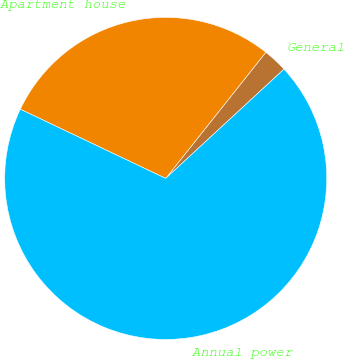<chart> <loc_0><loc_0><loc_500><loc_500><pie_chart><fcel>General<fcel>Apartment house<fcel>Annual power<nl><fcel>2.45%<fcel>28.61%<fcel>68.93%<nl></chart> 